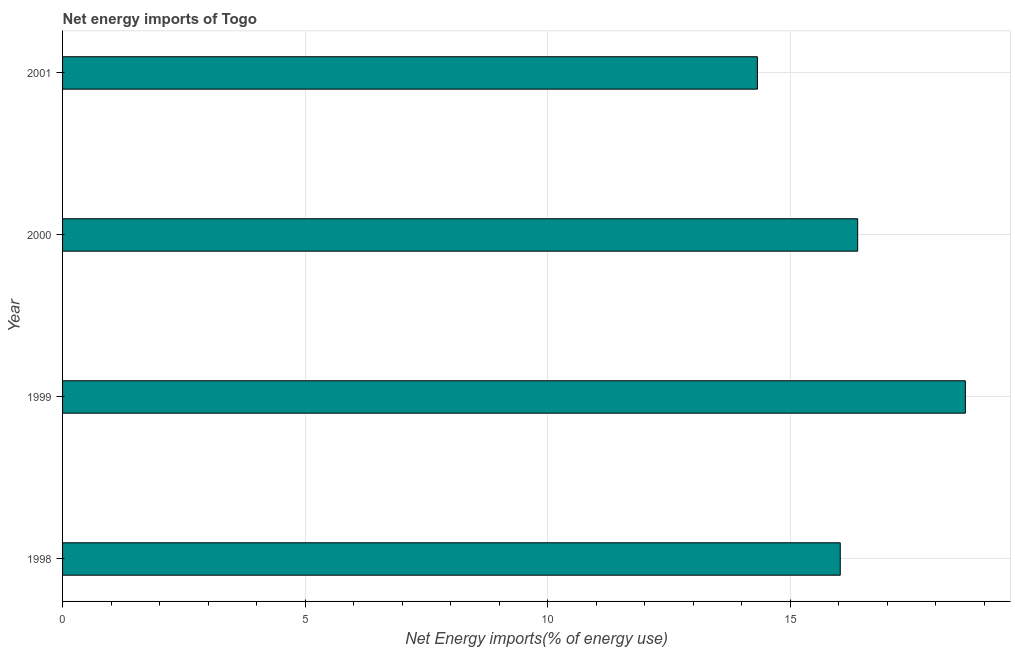Does the graph contain grids?
Your answer should be compact. Yes. What is the title of the graph?
Your answer should be compact. Net energy imports of Togo. What is the label or title of the X-axis?
Offer a very short reply. Net Energy imports(% of energy use). What is the label or title of the Y-axis?
Provide a succinct answer. Year. What is the energy imports in 1999?
Your answer should be very brief. 18.62. Across all years, what is the maximum energy imports?
Offer a terse response. 18.62. Across all years, what is the minimum energy imports?
Your response must be concise. 14.33. What is the sum of the energy imports?
Provide a succinct answer. 65.37. What is the difference between the energy imports in 1998 and 2000?
Ensure brevity in your answer.  -0.36. What is the average energy imports per year?
Provide a succinct answer. 16.34. What is the median energy imports?
Make the answer very short. 16.22. In how many years, is the energy imports greater than 13 %?
Make the answer very short. 4. Do a majority of the years between 1999 and 1998 (inclusive) have energy imports greater than 13 %?
Your answer should be very brief. No. What is the ratio of the energy imports in 1998 to that in 2001?
Your answer should be very brief. 1.12. What is the difference between the highest and the second highest energy imports?
Offer a very short reply. 2.22. Is the sum of the energy imports in 1999 and 2001 greater than the maximum energy imports across all years?
Your answer should be compact. Yes. What is the difference between the highest and the lowest energy imports?
Your answer should be compact. 4.29. Are all the bars in the graph horizontal?
Ensure brevity in your answer.  Yes. How many years are there in the graph?
Provide a succinct answer. 4. What is the difference between two consecutive major ticks on the X-axis?
Give a very brief answer. 5. What is the Net Energy imports(% of energy use) in 1998?
Ensure brevity in your answer.  16.04. What is the Net Energy imports(% of energy use) of 1999?
Your answer should be very brief. 18.62. What is the Net Energy imports(% of energy use) in 2000?
Your answer should be very brief. 16.39. What is the Net Energy imports(% of energy use) of 2001?
Provide a succinct answer. 14.33. What is the difference between the Net Energy imports(% of energy use) in 1998 and 1999?
Offer a terse response. -2.58. What is the difference between the Net Energy imports(% of energy use) in 1998 and 2000?
Make the answer very short. -0.36. What is the difference between the Net Energy imports(% of energy use) in 1998 and 2001?
Give a very brief answer. 1.71. What is the difference between the Net Energy imports(% of energy use) in 1999 and 2000?
Provide a short and direct response. 2.22. What is the difference between the Net Energy imports(% of energy use) in 1999 and 2001?
Make the answer very short. 4.29. What is the difference between the Net Energy imports(% of energy use) in 2000 and 2001?
Give a very brief answer. 2.07. What is the ratio of the Net Energy imports(% of energy use) in 1998 to that in 1999?
Your answer should be very brief. 0.86. What is the ratio of the Net Energy imports(% of energy use) in 1998 to that in 2000?
Your response must be concise. 0.98. What is the ratio of the Net Energy imports(% of energy use) in 1998 to that in 2001?
Provide a short and direct response. 1.12. What is the ratio of the Net Energy imports(% of energy use) in 1999 to that in 2000?
Provide a succinct answer. 1.14. What is the ratio of the Net Energy imports(% of energy use) in 1999 to that in 2001?
Make the answer very short. 1.3. What is the ratio of the Net Energy imports(% of energy use) in 2000 to that in 2001?
Make the answer very short. 1.14. 